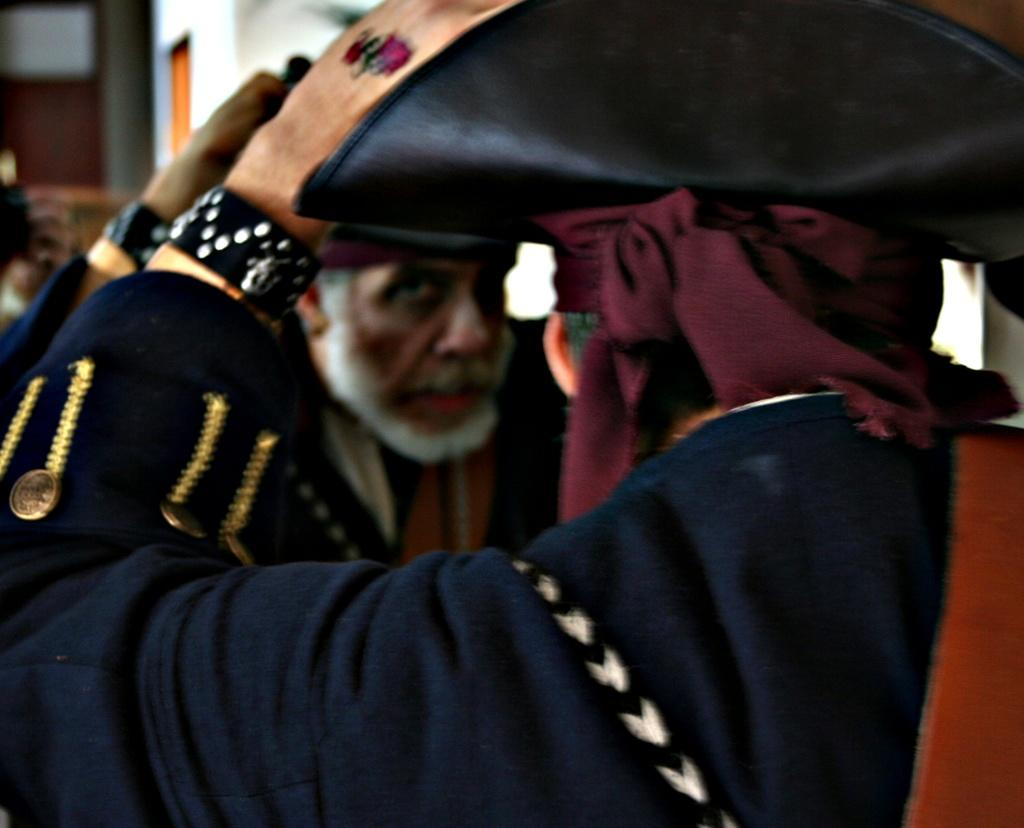Who or what is present in the image? There is a person in the image. What is the person wearing on their head? The person is wearing a hat. What accessory is the person wearing on their wrist? The person is wearing a wristband. What object in the image allows for self-reflection? There is a mirror in the image, which reflects the person. What type of wheel can be seen on the person's lip in the image? There is no wheel present on the person's lip in the image. What kind of spark is visible near the person's hat in the image? There is no spark visible near the person's hat in the image. 